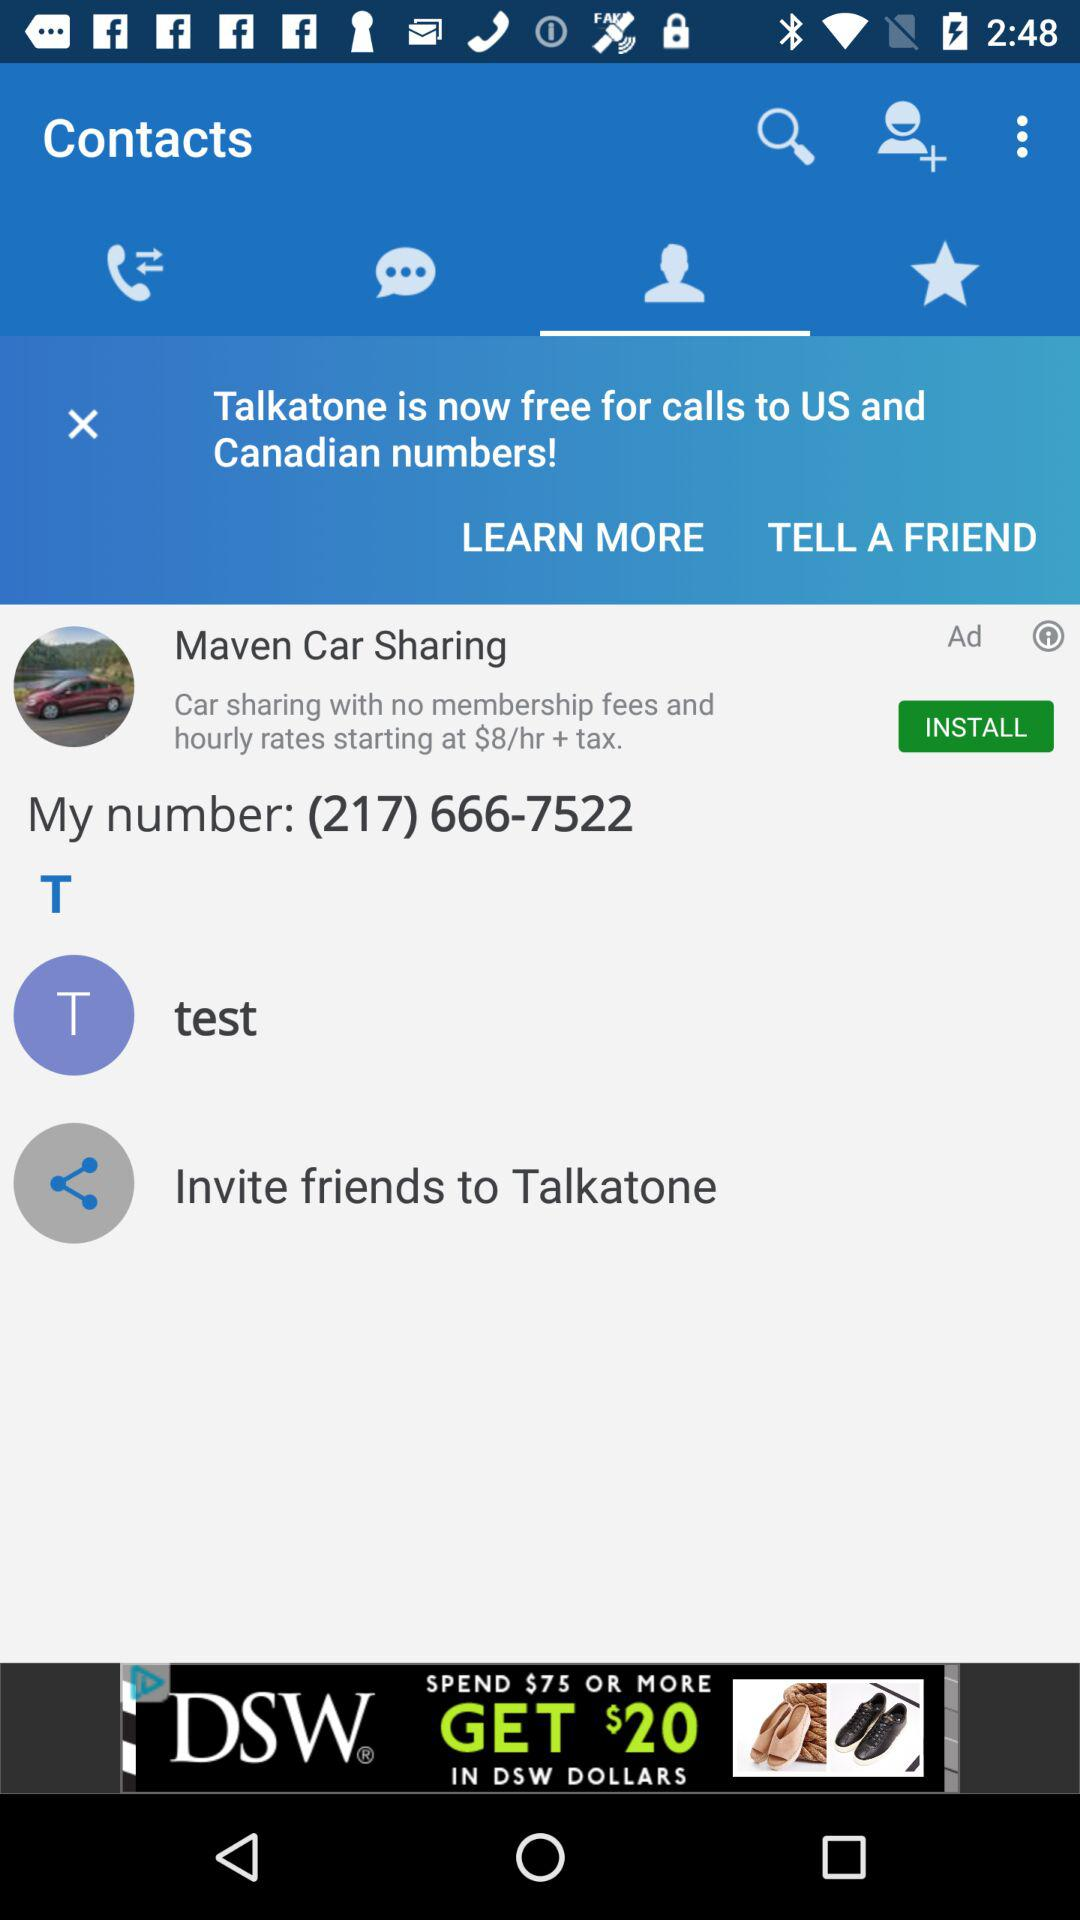What is my phone number? Your phone number is (217) 666-7522. 